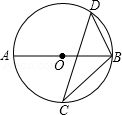What mathematical concepts does this diagram illustrate, based on its geometric properties? This diagram is a rich illustration of several mathematical concepts. First, there's Thales' theorem, which states that any angle inscribed in a semicircle is a right angle. It also demonstrates the inscribed angle theorem, where the angle inscribed in the circle is half the measure of the central angle subtended by the same arc. Additionally, the properties of cyclic quadrilaterals and the relationship between the angles are revealed. Furthermore, the diagram could lead into discussions about the Law of Sines in triangle ACD or BCD and the concept of similar triangles. 